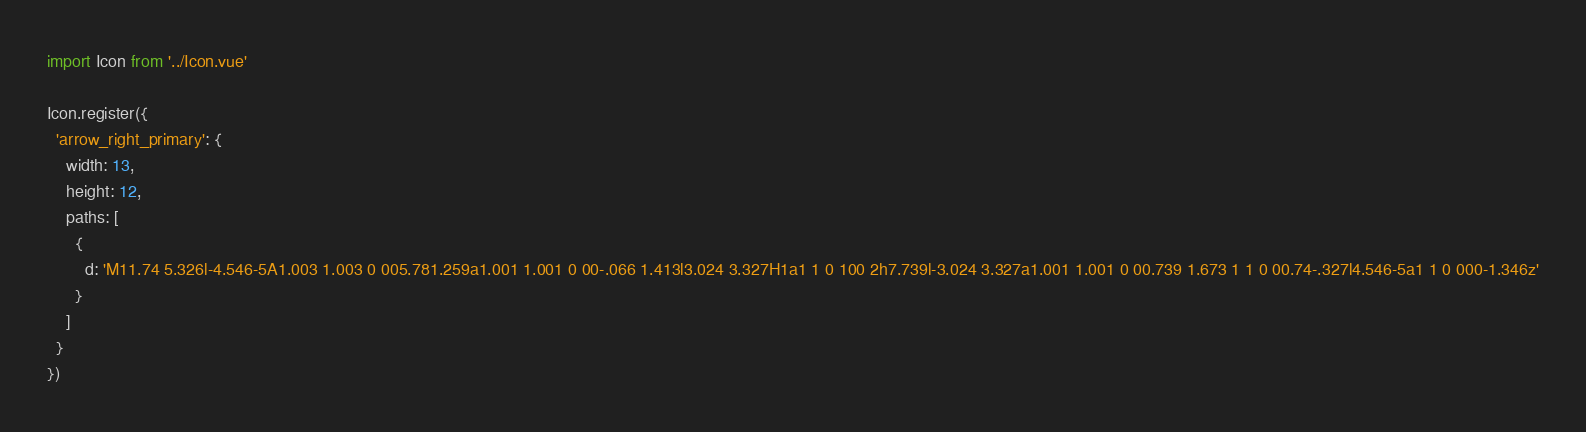Convert code to text. <code><loc_0><loc_0><loc_500><loc_500><_JavaScript_>import Icon from '../Icon.vue'

Icon.register({
  'arrow_right_primary': {
    width: 13,
    height: 12,
    paths: [
      {
        d: 'M11.74 5.326l-4.546-5A1.003 1.003 0 005.781.259a1.001 1.001 0 00-.066 1.413l3.024 3.327H1a1 1 0 100 2h7.739l-3.024 3.327a1.001 1.001 0 00.739 1.673 1 1 0 00.74-.327l4.546-5a1 1 0 000-1.346z'
      }
    ]
  }
})
</code> 